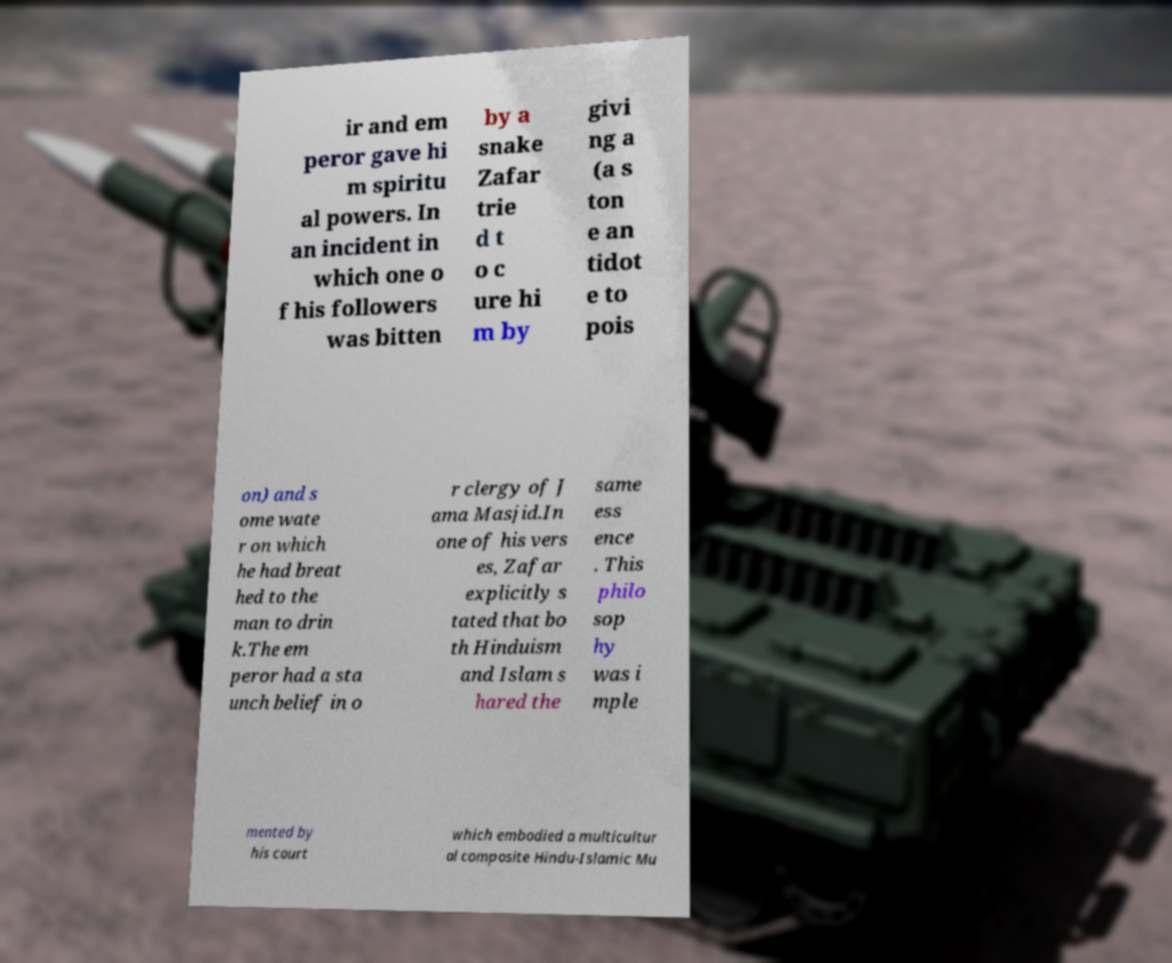There's text embedded in this image that I need extracted. Can you transcribe it verbatim? ir and em peror gave hi m spiritu al powers. In an incident in which one o f his followers was bitten by a snake Zafar trie d t o c ure hi m by givi ng a (a s ton e an tidot e to pois on) and s ome wate r on which he had breat hed to the man to drin k.The em peror had a sta unch belief in o r clergy of J ama Masjid.In one of his vers es, Zafar explicitly s tated that bo th Hinduism and Islam s hared the same ess ence . This philo sop hy was i mple mented by his court which embodied a multicultur al composite Hindu-Islamic Mu 